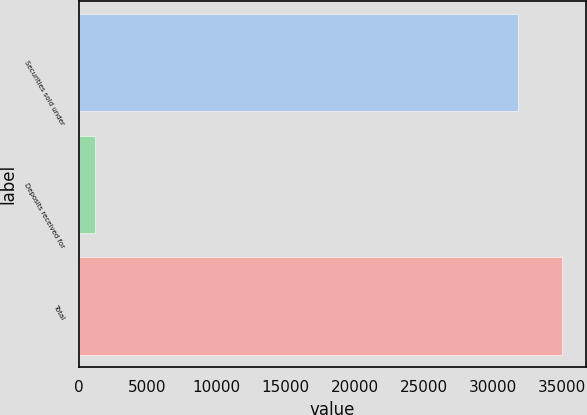Convert chart. <chart><loc_0><loc_0><loc_500><loc_500><bar_chart><fcel>Securities sold under<fcel>Deposits received for<fcel>Total<nl><fcel>31831<fcel>1181<fcel>35014.1<nl></chart> 